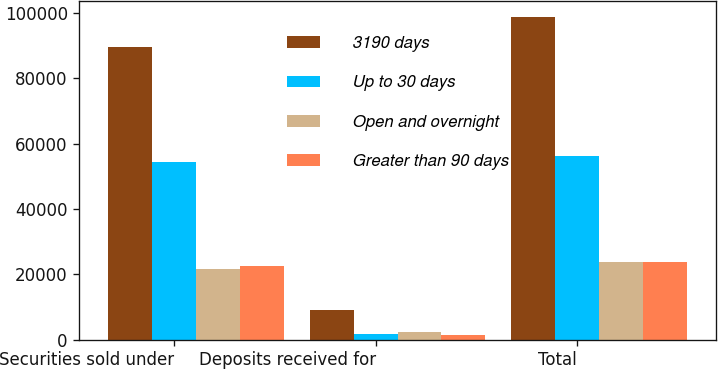Convert chart to OTSL. <chart><loc_0><loc_0><loc_500><loc_500><stacked_bar_chart><ecel><fcel>Securities sold under<fcel>Deposits received for<fcel>Total<nl><fcel>3190 days<fcel>89732<fcel>9096<fcel>98828<nl><fcel>Up to 30 days<fcel>54336<fcel>1823<fcel>56159<nl><fcel>Open and overnight<fcel>21541<fcel>2324<fcel>23865<nl><fcel>Greater than 90 days<fcel>22431<fcel>1414<fcel>23845<nl></chart> 